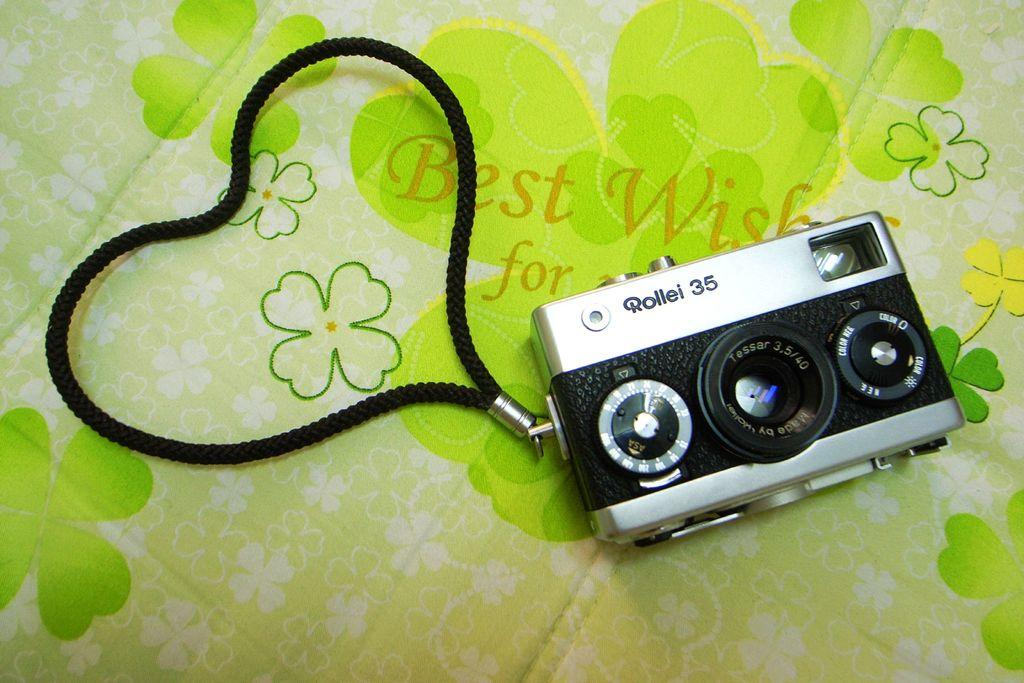<image>
Offer a succinct explanation of the picture presented. A Rollei 35 camera sitting on a tablecloth with a green flower design. 